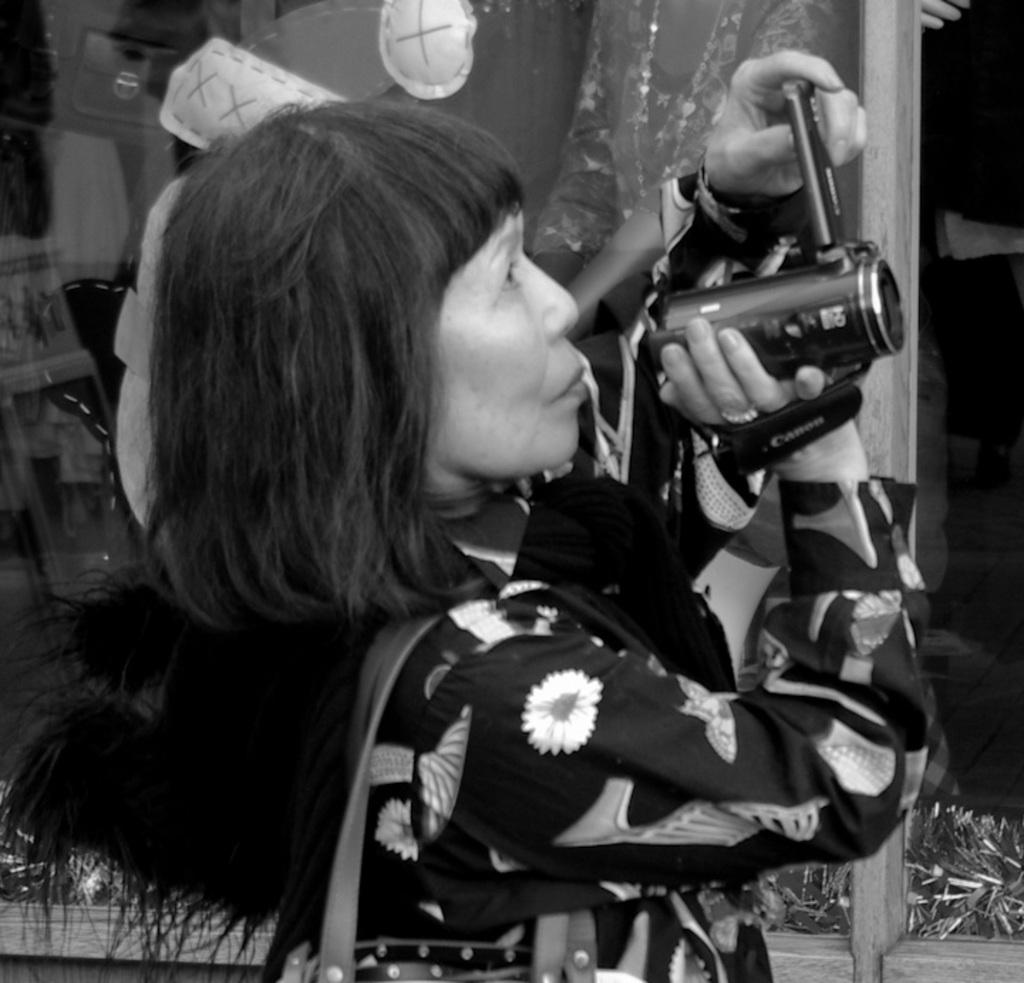What is the woman in the image doing? The woman is standing in the image and holding a camera. What might the woman be capturing with her camera? The woman is capturing something, which could be a scene, an object, or a person. Can you describe any architectural features in the image? Yes, there is a glass wall in the image. What type of drug is the woman administering to the patient in the image? There is no patient or drug present in the image; it features a woman holding a camera and a glass wall. 